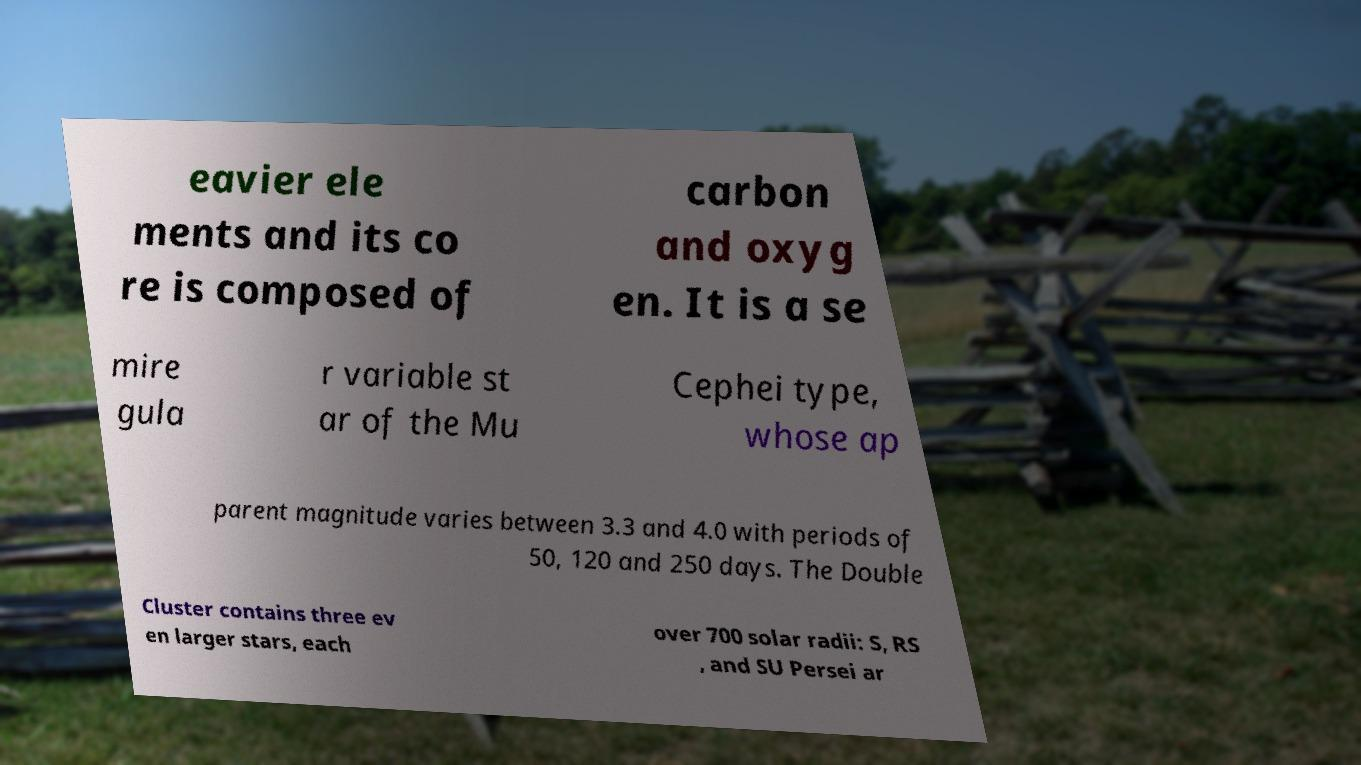Please identify and transcribe the text found in this image. eavier ele ments and its co re is composed of carbon and oxyg en. It is a se mire gula r variable st ar of the Mu Cephei type, whose ap parent magnitude varies between 3.3 and 4.0 with periods of 50, 120 and 250 days. The Double Cluster contains three ev en larger stars, each over 700 solar radii: S, RS , and SU Persei ar 